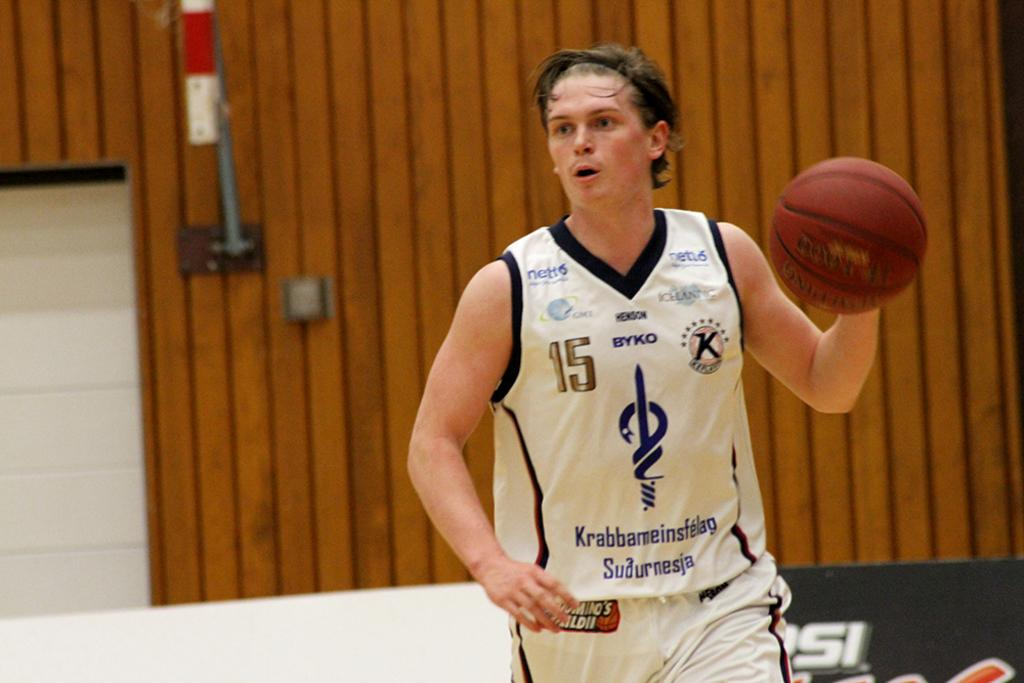<image>
Describe the image concisely. Number 15 runs with a basketball in his left hand. 